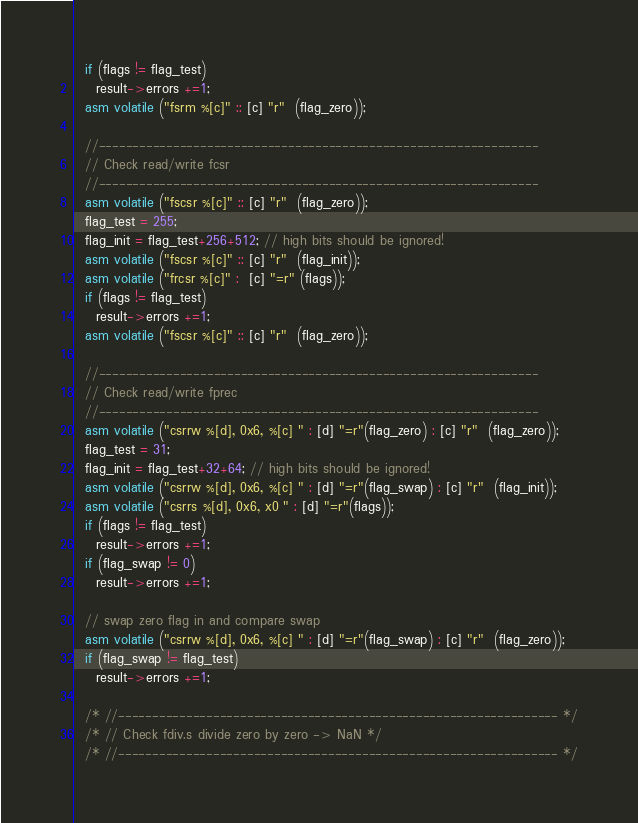<code> <loc_0><loc_0><loc_500><loc_500><_C_>  if (flags != flag_test)
    result->errors +=1;
  asm volatile ("fsrm %[c]" :: [c] "r"  (flag_zero));

  //-----------------------------------------------------------------
  // Check read/write fcsr
  //-----------------------------------------------------------------
  asm volatile ("fscsr %[c]" :: [c] "r"  (flag_zero));
  flag_test = 255;
  flag_init = flag_test+256+512; // high bits should be ignored!
  asm volatile ("fscsr %[c]" :: [c] "r"  (flag_init));
  asm volatile ("frcsr %[c]" :  [c] "=r" (flags));
  if (flags != flag_test)
    result->errors +=1;
  asm volatile ("fscsr %[c]" :: [c] "r"  (flag_zero));

  //-----------------------------------------------------------------
  // Check read/write fprec
  //-----------------------------------------------------------------
  asm volatile ("csrrw %[d], 0x6, %[c] " : [d] "=r"(flag_zero) : [c] "r"  (flag_zero));
  flag_test = 31;
  flag_init = flag_test+32+64; // high bits should be ignored!
  asm volatile ("csrrw %[d], 0x6, %[c] " : [d] "=r"(flag_swap) : [c] "r"  (flag_init));
  asm volatile ("csrrs %[d], 0x6, x0 " : [d] "=r"(flags));
  if (flags != flag_test)
    result->errors +=1;
  if (flag_swap != 0)
    result->errors +=1;

  // swap zero flag in and compare swap
  asm volatile ("csrrw %[d], 0x6, %[c] " : [d] "=r"(flag_swap) : [c] "r"  (flag_zero));
  if (flag_swap != flag_test)
    result->errors +=1;

  /* //----------------------------------------------------------------- */
  /* // Check fdiv.s divide zero by zero -> NaN */
  /* //----------------------------------------------------------------- */</code> 